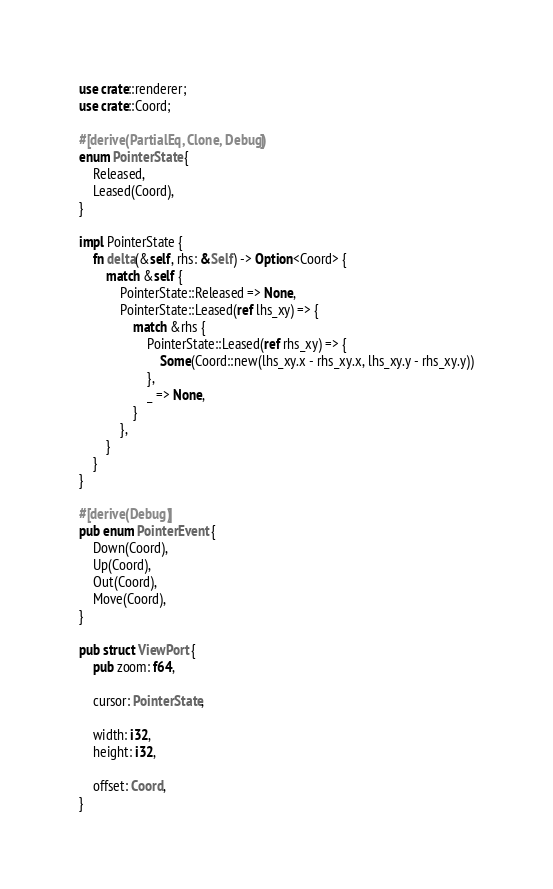Convert code to text. <code><loc_0><loc_0><loc_500><loc_500><_Rust_>use crate::renderer;
use crate::Coord;

#[derive(PartialEq, Clone, Debug)]
enum PointerState {
    Released,
    Leased(Coord),
}

impl PointerState {
    fn delta(&self, rhs: &Self) -> Option<Coord> {
        match &self {
            PointerState::Released => None,
            PointerState::Leased(ref lhs_xy) => {
                match &rhs {
                    PointerState::Leased(ref rhs_xy) => {
                        Some(Coord::new(lhs_xy.x - rhs_xy.x, lhs_xy.y - rhs_xy.y))
                    },
                    _ => None,
                }
            },
        }
    }
}

#[derive(Debug)]
pub enum PointerEvent {
    Down(Coord),
    Up(Coord),
    Out(Coord),
    Move(Coord),
}

pub struct ViewPort {
    pub zoom: f64,

    cursor: PointerState,

    width: i32,
    height: i32,

    offset: Coord,
}</code> 